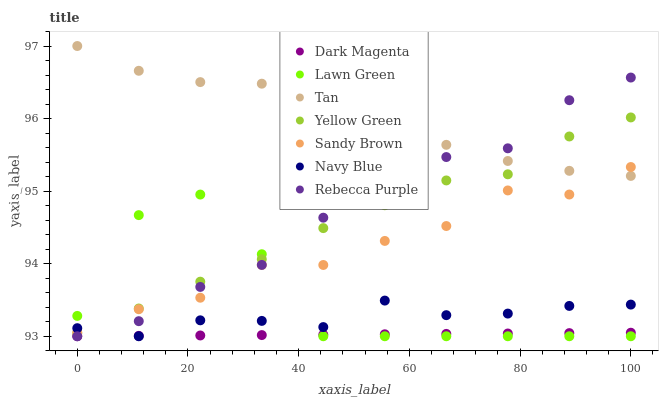Does Dark Magenta have the minimum area under the curve?
Answer yes or no. Yes. Does Tan have the maximum area under the curve?
Answer yes or no. Yes. Does Navy Blue have the minimum area under the curve?
Answer yes or no. No. Does Navy Blue have the maximum area under the curve?
Answer yes or no. No. Is Dark Magenta the smoothest?
Answer yes or no. Yes. Is Lawn Green the roughest?
Answer yes or no. Yes. Is Navy Blue the smoothest?
Answer yes or no. No. Is Navy Blue the roughest?
Answer yes or no. No. Does Lawn Green have the lowest value?
Answer yes or no. Yes. Does Tan have the lowest value?
Answer yes or no. No. Does Tan have the highest value?
Answer yes or no. Yes. Does Navy Blue have the highest value?
Answer yes or no. No. Is Dark Magenta less than Tan?
Answer yes or no. Yes. Is Yellow Green greater than Dark Magenta?
Answer yes or no. Yes. Does Tan intersect Rebecca Purple?
Answer yes or no. Yes. Is Tan less than Rebecca Purple?
Answer yes or no. No. Is Tan greater than Rebecca Purple?
Answer yes or no. No. Does Dark Magenta intersect Tan?
Answer yes or no. No. 